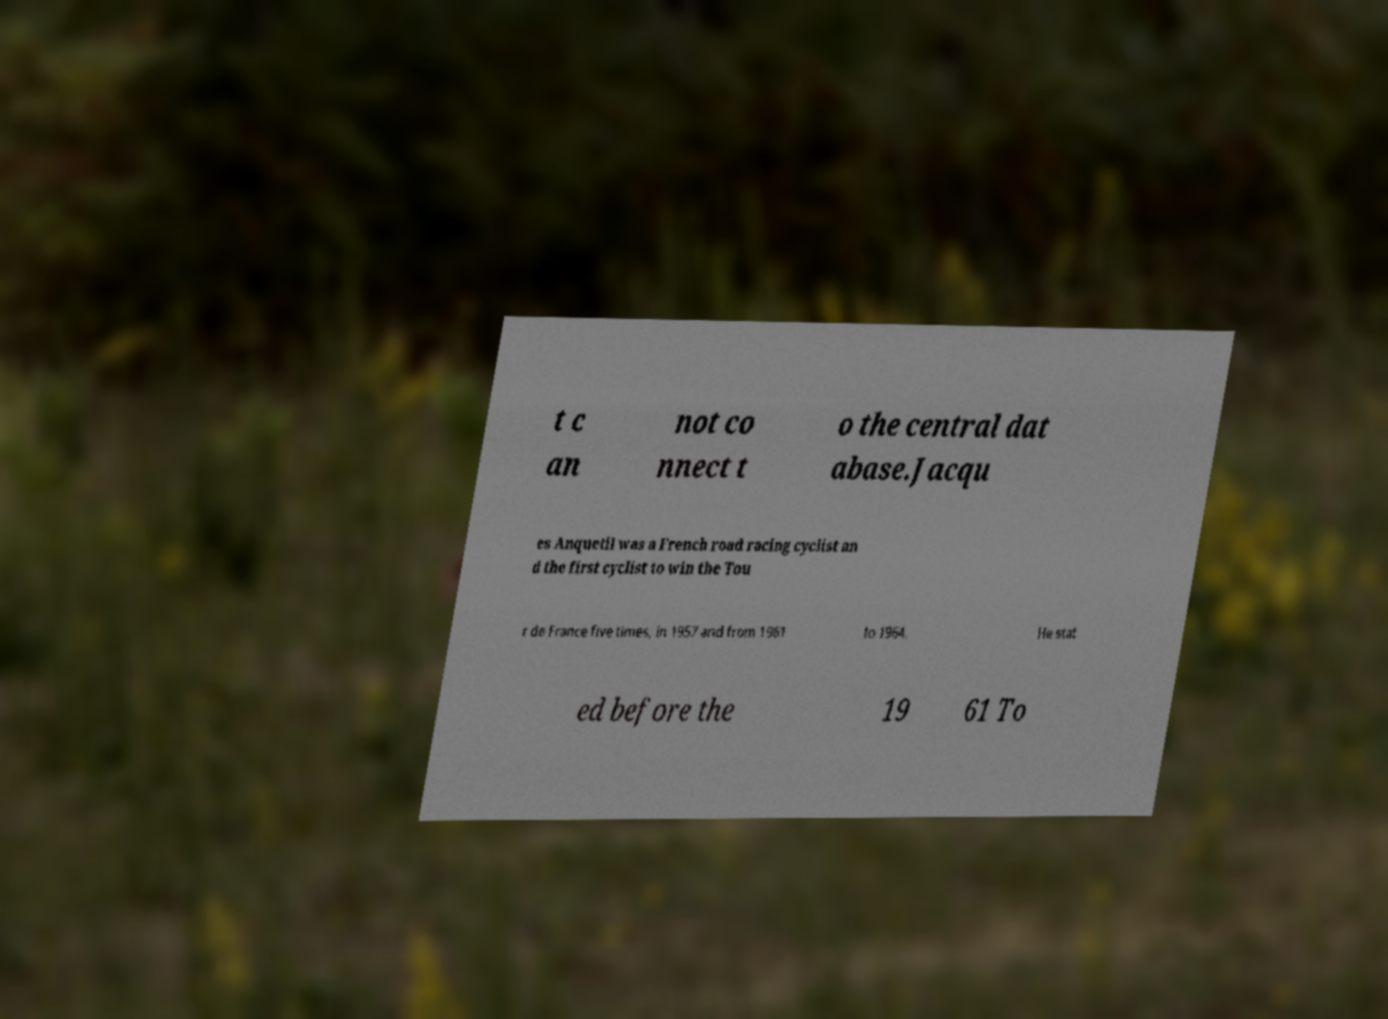Please identify and transcribe the text found in this image. t c an not co nnect t o the central dat abase.Jacqu es Anquetil was a French road racing cyclist an d the first cyclist to win the Tou r de France five times, in 1957 and from 1961 to 1964. He stat ed before the 19 61 To 